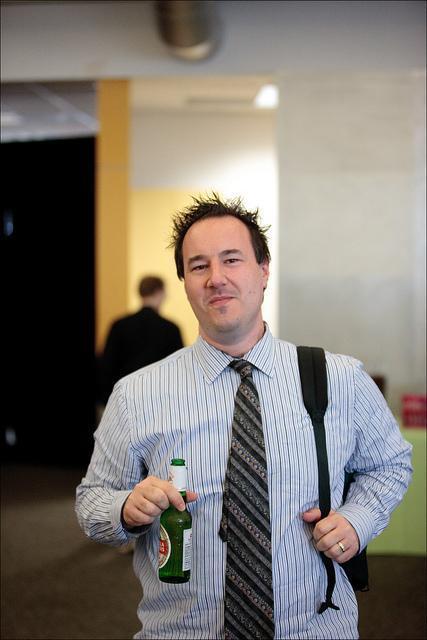How many people are in the photo?
Give a very brief answer. 2. How many backpacks are there?
Give a very brief answer. 1. 